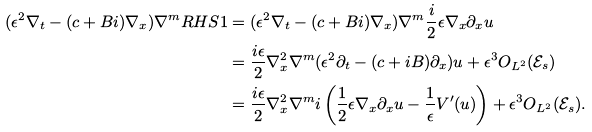<formula> <loc_0><loc_0><loc_500><loc_500>( \epsilon ^ { 2 } \nabla _ { t } - ( c + B i ) \nabla _ { x } ) \nabla ^ { m } R H S 1 & = ( \epsilon ^ { 2 } \nabla _ { t } - ( c + B i ) \nabla _ { x } ) \nabla ^ { m } \frac { i } { 2 } \epsilon \nabla _ { x } \partial _ { x } u \\ & = \frac { i \epsilon } { 2 } \nabla _ { x } ^ { 2 } \nabla ^ { m } ( \epsilon ^ { 2 } \partial _ { t } - ( c + i B ) \partial _ { x } ) u + \epsilon ^ { 3 } O _ { L ^ { 2 } } ( \mathcal { E } _ { s } ) \\ & = \frac { i \epsilon } { 2 } \nabla _ { x } ^ { 2 } \nabla ^ { m } i \left ( \frac { 1 } { 2 } \epsilon \nabla _ { x } \partial _ { x } u - \frac { 1 } { \epsilon } V ^ { \prime } ( u ) \right ) + \epsilon ^ { 3 } O _ { L ^ { 2 } } ( \mathcal { E } _ { s } ) .</formula> 